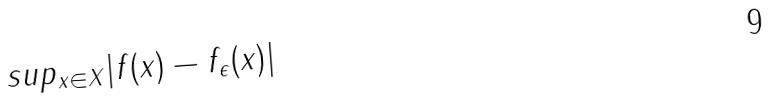Convert formula to latex. <formula><loc_0><loc_0><loc_500><loc_500>s u p _ { x \in X } | f ( x ) - f _ { \epsilon } ( x ) |</formula> 